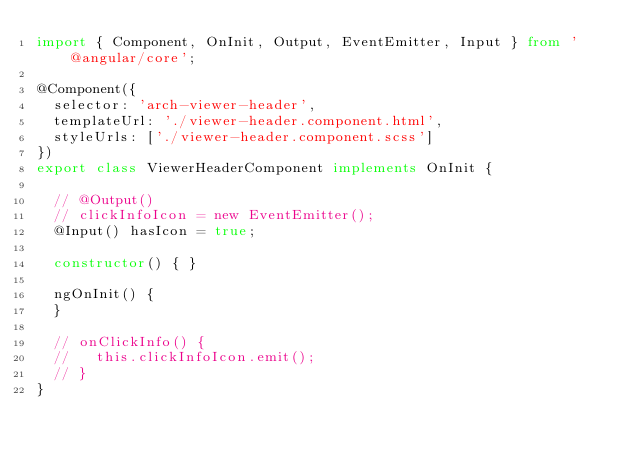Convert code to text. <code><loc_0><loc_0><loc_500><loc_500><_TypeScript_>import { Component, OnInit, Output, EventEmitter, Input } from '@angular/core';

@Component({
  selector: 'arch-viewer-header',
  templateUrl: './viewer-header.component.html',
  styleUrls: ['./viewer-header.component.scss']
})
export class ViewerHeaderComponent implements OnInit {

  // @Output()
  // clickInfoIcon = new EventEmitter();
  @Input() hasIcon = true;

  constructor() { }

  ngOnInit() {
  }

  // onClickInfo() {
  //   this.clickInfoIcon.emit();
  // }
}
</code> 